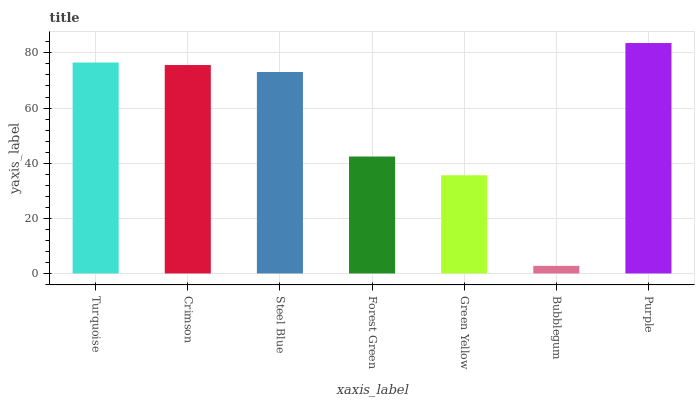Is Bubblegum the minimum?
Answer yes or no. Yes. Is Purple the maximum?
Answer yes or no. Yes. Is Crimson the minimum?
Answer yes or no. No. Is Crimson the maximum?
Answer yes or no. No. Is Turquoise greater than Crimson?
Answer yes or no. Yes. Is Crimson less than Turquoise?
Answer yes or no. Yes. Is Crimson greater than Turquoise?
Answer yes or no. No. Is Turquoise less than Crimson?
Answer yes or no. No. Is Steel Blue the high median?
Answer yes or no. Yes. Is Steel Blue the low median?
Answer yes or no. Yes. Is Bubblegum the high median?
Answer yes or no. No. Is Turquoise the low median?
Answer yes or no. No. 